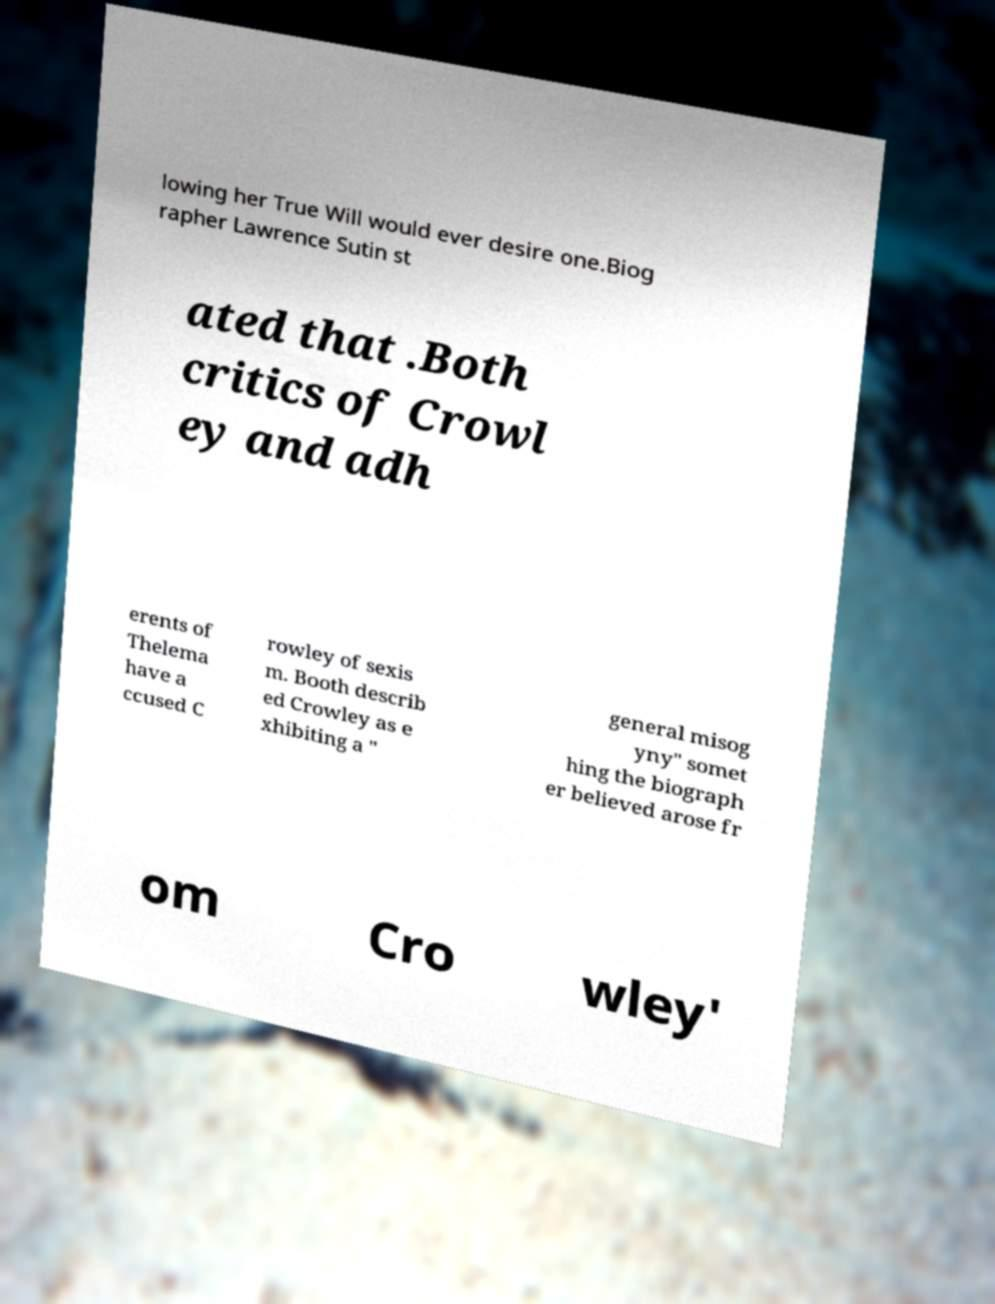Please read and relay the text visible in this image. What does it say? lowing her True Will would ever desire one.Biog rapher Lawrence Sutin st ated that .Both critics of Crowl ey and adh erents of Thelema have a ccused C rowley of sexis m. Booth describ ed Crowley as e xhibiting a " general misog yny" somet hing the biograph er believed arose fr om Cro wley' 